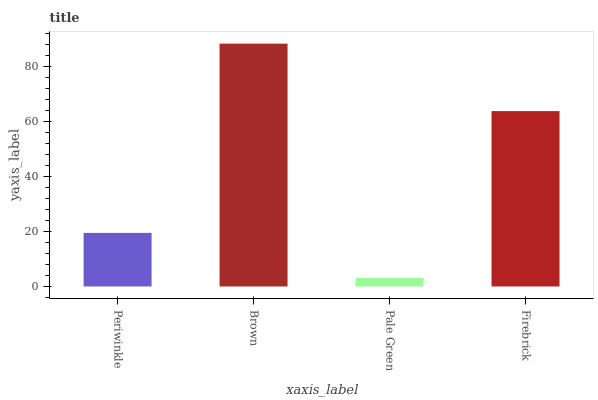Is Pale Green the minimum?
Answer yes or no. Yes. Is Brown the maximum?
Answer yes or no. Yes. Is Brown the minimum?
Answer yes or no. No. Is Pale Green the maximum?
Answer yes or no. No. Is Brown greater than Pale Green?
Answer yes or no. Yes. Is Pale Green less than Brown?
Answer yes or no. Yes. Is Pale Green greater than Brown?
Answer yes or no. No. Is Brown less than Pale Green?
Answer yes or no. No. Is Firebrick the high median?
Answer yes or no. Yes. Is Periwinkle the low median?
Answer yes or no. Yes. Is Brown the high median?
Answer yes or no. No. Is Firebrick the low median?
Answer yes or no. No. 